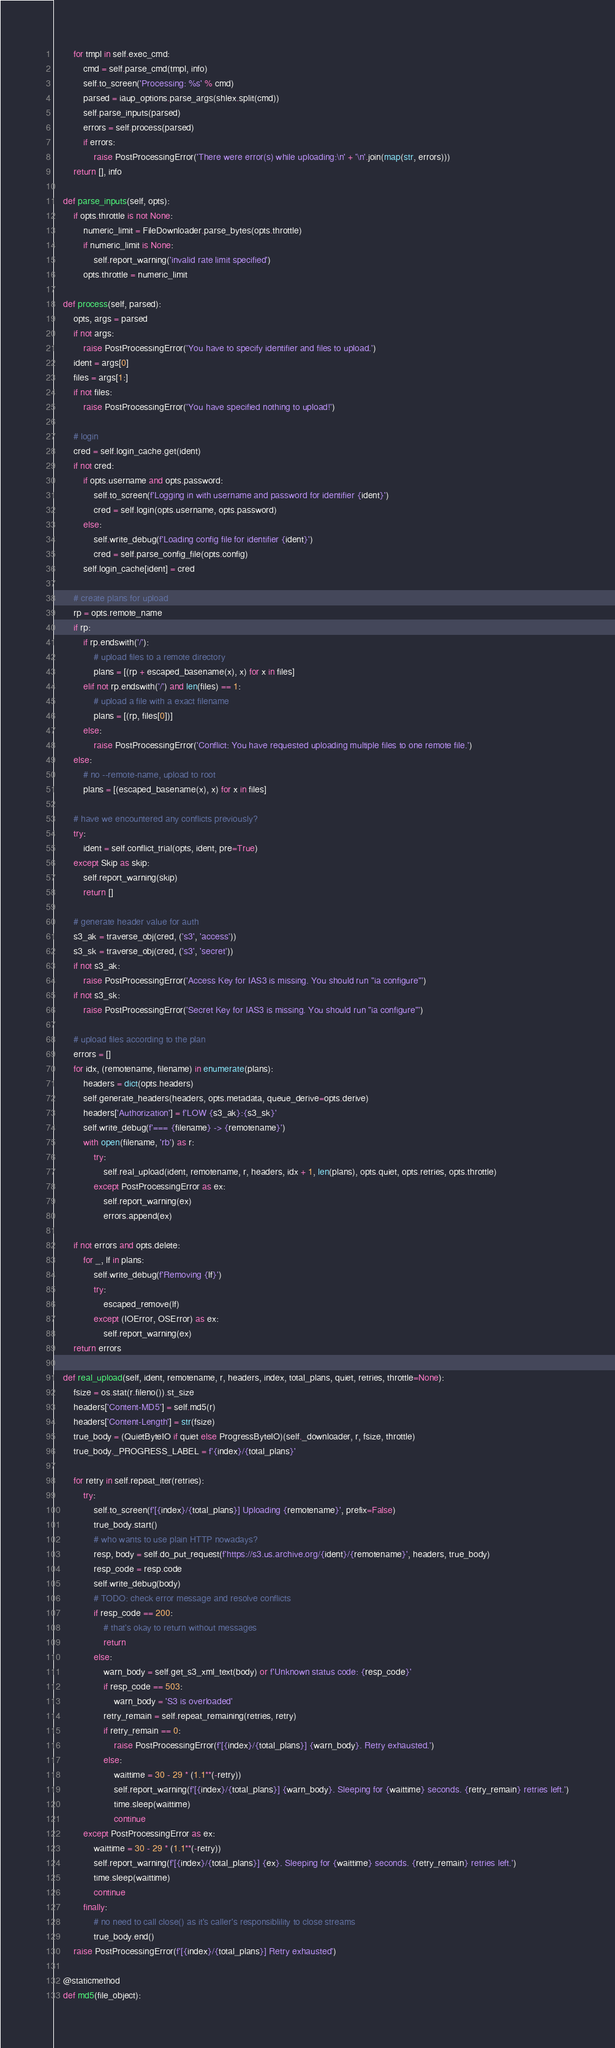<code> <loc_0><loc_0><loc_500><loc_500><_Python_>        for tmpl in self.exec_cmd:
            cmd = self.parse_cmd(tmpl, info)
            self.to_screen('Processing: %s' % cmd)
            parsed = iaup_options.parse_args(shlex.split(cmd))
            self.parse_inputs(parsed)
            errors = self.process(parsed)
            if errors:
                raise PostProcessingError('There were error(s) while uploading:\n' + '\n'.join(map(str, errors)))
        return [], info

    def parse_inputs(self, opts):
        if opts.throttle is not None:
            numeric_limit = FileDownloader.parse_bytes(opts.throttle)
            if numeric_limit is None:
                self.report_warning('invalid rate limit specified')
            opts.throttle = numeric_limit

    def process(self, parsed):
        opts, args = parsed
        if not args:
            raise PostProcessingError('You have to specify identifier and files to upload.')
        ident = args[0]
        files = args[1:]
        if not files:
            raise PostProcessingError('You have specified nothing to upload!')

        # login
        cred = self.login_cache.get(ident)
        if not cred:
            if opts.username and opts.password:
                self.to_screen(f'Logging in with username and password for identifier {ident}')
                cred = self.login(opts.username, opts.password)
            else:
                self.write_debug(f'Loading config file for identifier {ident}')
                cred = self.parse_config_file(opts.config)
            self.login_cache[ident] = cred

        # create plans for upload
        rp = opts.remote_name
        if rp:
            if rp.endswith('/'):
                # upload files to a remote directory
                plans = [(rp + escaped_basename(x), x) for x in files]
            elif not rp.endswith('/') and len(files) == 1:
                # upload a file with a exact filename
                plans = [(rp, files[0])]
            else:
                raise PostProcessingError('Conflict: You have requested uploading multiple files to one remote file.')
        else:
            # no --remote-name, upload to root
            plans = [(escaped_basename(x), x) for x in files]

        # have we encountered any conflicts previously?
        try:
            ident = self.conflict_trial(opts, ident, pre=True)
        except Skip as skip:
            self.report_warning(skip)
            return []

        # generate header value for auth
        s3_ak = traverse_obj(cred, ('s3', 'access'))
        s3_sk = traverse_obj(cred, ('s3', 'secret'))
        if not s3_ak:
            raise PostProcessingError('Access Key for IAS3 is missing. You should run "ia configure"')
        if not s3_sk:
            raise PostProcessingError('Secret Key for IAS3 is missing. You should run "ia configure"')

        # upload files according to the plan
        errors = []
        for idx, (remotename, filename) in enumerate(plans):
            headers = dict(opts.headers)
            self.generate_headers(headers, opts.metadata, queue_derive=opts.derive)
            headers['Authorization'] = f'LOW {s3_ak}:{s3_sk}'
            self.write_debug(f'=== {filename} -> {remotename}')
            with open(filename, 'rb') as r:
                try:
                    self.real_upload(ident, remotename, r, headers, idx + 1, len(plans), opts.quiet, opts.retries, opts.throttle)
                except PostProcessingError as ex:
                    self.report_warning(ex)
                    errors.append(ex)

        if not errors and opts.delete:
            for _, lf in plans:
                self.write_debug(f'Removing {lf}')
                try:
                    escaped_remove(lf)
                except (IOError, OSError) as ex:
                    self.report_warning(ex)
        return errors

    def real_upload(self, ident, remotename, r, headers, index, total_plans, quiet, retries, throttle=None):
        fsize = os.stat(r.fileno()).st_size
        headers['Content-MD5'] = self.md5(r)
        headers['Content-Length'] = str(fsize)
        true_body = (QuietByteIO if quiet else ProgressByteIO)(self._downloader, r, fsize, throttle)
        true_body._PROGRESS_LABEL = f'{index}/{total_plans}'

        for retry in self.repeat_iter(retries):
            try:
                self.to_screen(f'[{index}/{total_plans}] Uploading {remotename}', prefix=False)
                true_body.start()
                # who wants to use plain HTTP nowadays?
                resp, body = self.do_put_request(f'https://s3.us.archive.org/{ident}/{remotename}', headers, true_body)
                resp_code = resp.code
                self.write_debug(body)
                # TODO: check error message and resolve conflicts
                if resp_code == 200:
                    # that's okay to return without messages
                    return
                else:
                    warn_body = self.get_s3_xml_text(body) or f'Unknown status code: {resp_code}'
                    if resp_code == 503:
                        warn_body = 'S3 is overloaded'
                    retry_remain = self.repeat_remaining(retries, retry)
                    if retry_remain == 0:
                        raise PostProcessingError(f'[{index}/{total_plans}] {warn_body}. Retry exhausted.')
                    else:
                        waittime = 30 - 29 * (1.1**(-retry))
                        self.report_warning(f'[{index}/{total_plans}] {warn_body}. Sleeping for {waittime} seconds. {retry_remain} retries left.')
                        time.sleep(waittime)
                        continue
            except PostProcessingError as ex:
                waittime = 30 - 29 * (1.1**(-retry))
                self.report_warning(f'[{index}/{total_plans}] {ex}. Sleeping for {waittime} seconds. {retry_remain} retries left.')
                time.sleep(waittime)
                continue
            finally:
                # no need to call close() as it's caller's responsiblility to close streams
                true_body.end()
        raise PostProcessingError(f'[{index}/{total_plans}] Retry exhausted')

    @staticmethod
    def md5(file_object):</code> 